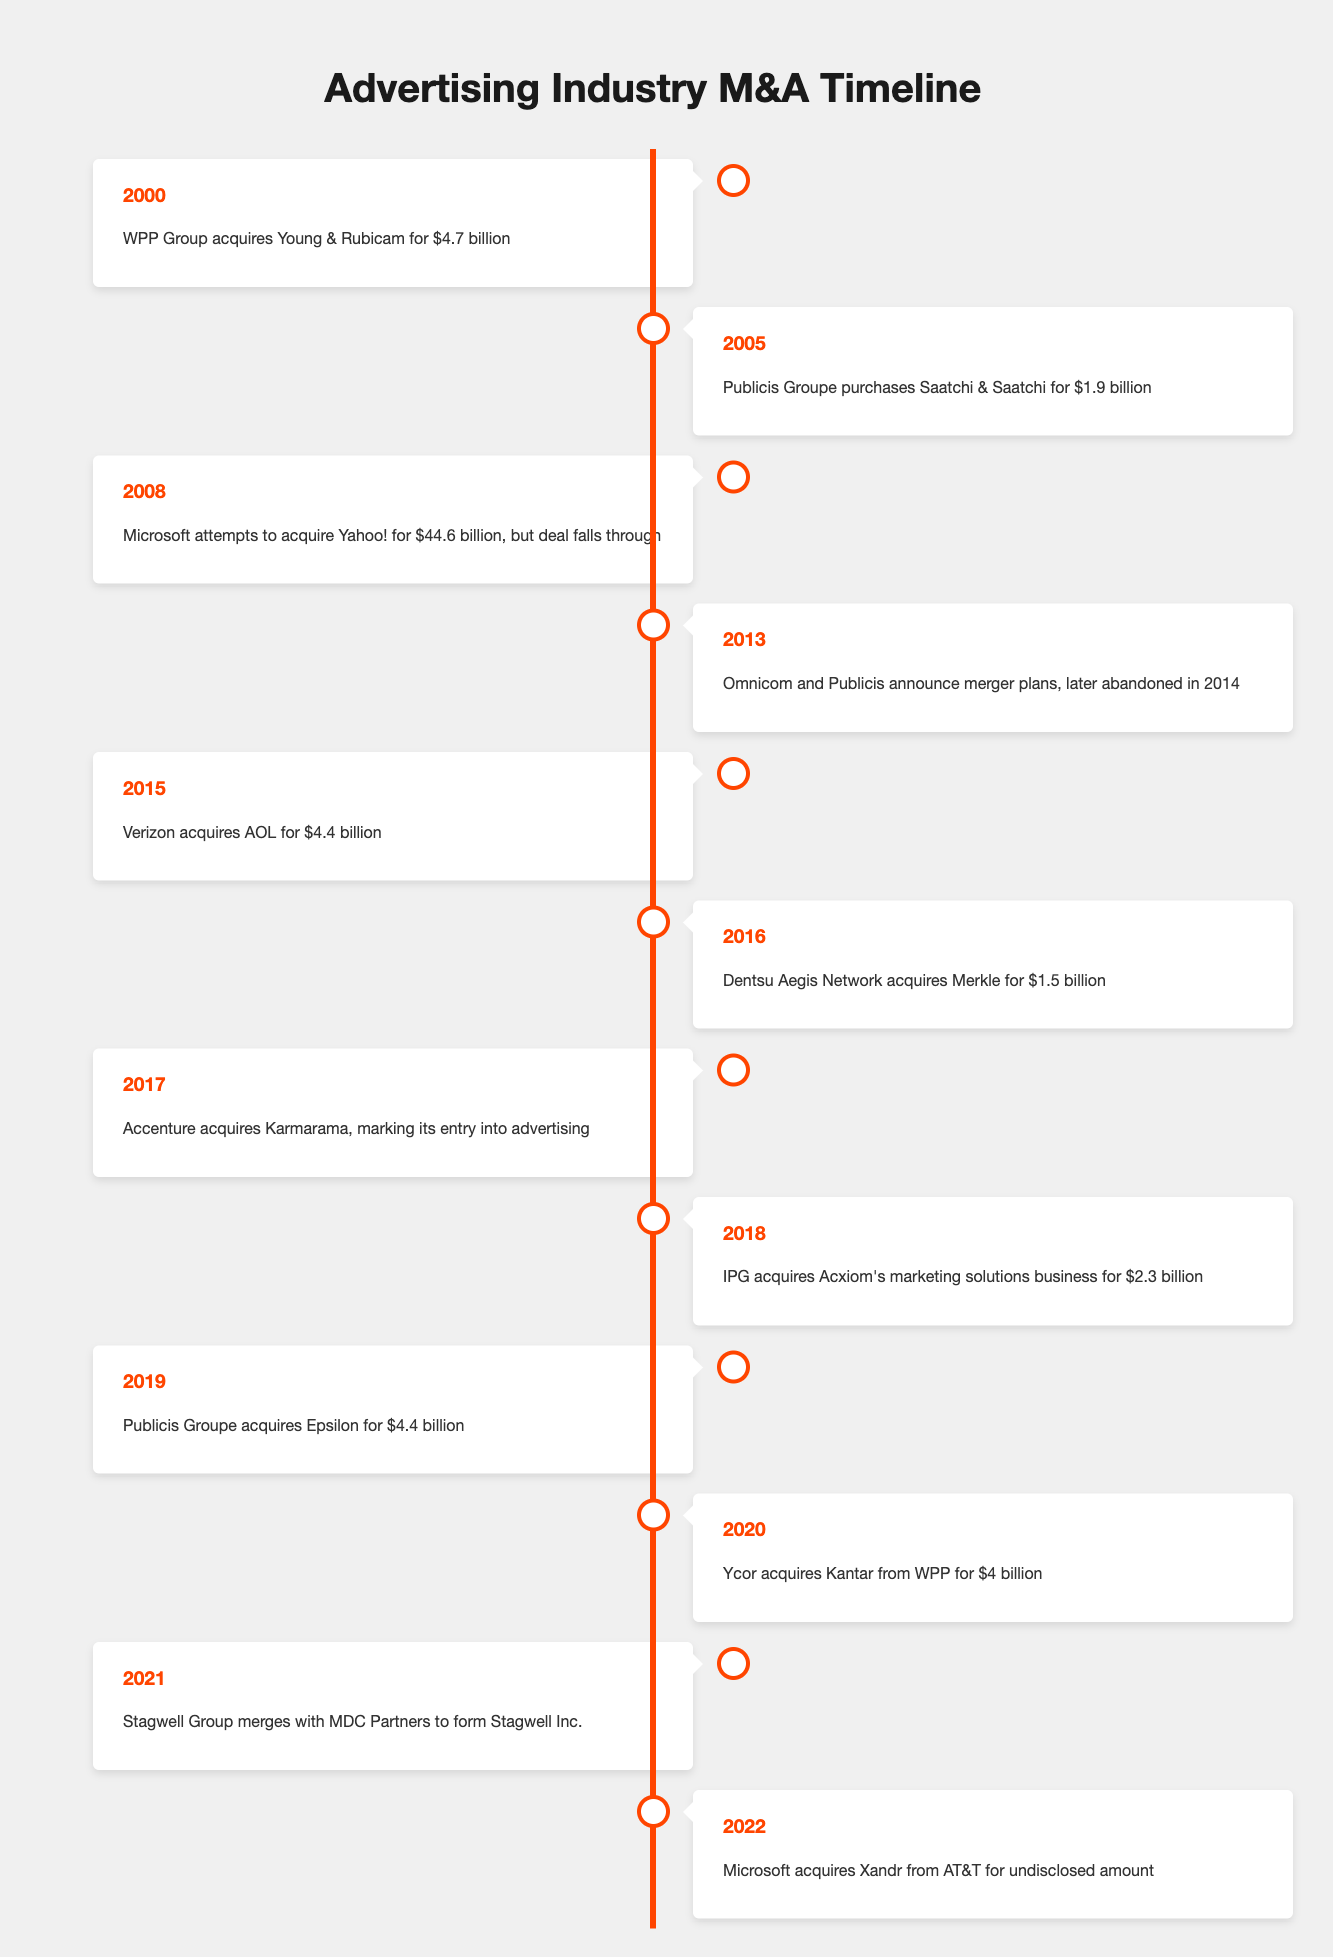What year did WPP Group acquire Young & Rubicam? The table shows that WPP Group acquired Young & Rubicam in the year 2000.
Answer: 2000 How much did Publicis Groupe pay for Saatchi & Saatchi? According to the table, Publicis Groupe purchased Saatchi & Saatchi for $1.9 billion.
Answer: $1.9 billion Was the acquisition of Yahoo! by Microsoft successful? The table states that Microsoft attempted to acquire Yahoo! for $44.6 billion in 2008, but the deal fell through. This indicates it was not successful.
Answer: No How many acquisitions or mergers occurred in the year 2019? The timeline indicates that Publicis Groupe acquired Epsilon for $4.4 billion in 2019. Thus, there was one acquisition that year.
Answer: 1 What is the total amount spent on the acquisitions from 2000 to 2016? To find the total, we add the following amounts: $4.7 billion (WPP Group) + $1.9 billion (Publicis Groupe) + $44.6 billion (Microsoft) + $4.4 billion (Verizon) + $1.5 billion (Dentsu Aegis) = $58.1 billion. Thus, the total amount is $58.1 billion.
Answer: $58.1 billion Did any acquisitions occur between 2014 and 2018? Analyzing the timeline, it shows that there was an acquisition in 2016 (Dentsu Aegis) and 2018 (IPG), which indicates that yes, there were acquisitions during that period.
Answer: Yes Which company acquired Kantar, and what was the acquisition amount? Ycor acquired Kantar from WPP for $4 billion, as indicated in the table under the year 2020.
Answer: Ycor; $4 billion What years did Publicis Groupe make significant acquisitions? The table notes that Publicis Groupe made significant acquisitions in 2005 (Saatchi & Saatchi) and 2019 (Epsilon), indicating they were active in both years.
Answer: 2005, 2019 How many companies did Accenture acquire between 2017 and 2022? From the given years, the data shows that Accenture acquired Karmarama in 2017. There are no other acquisitions listed for Accenture up to 2022, so they acquired one company during this time.
Answer: 1 